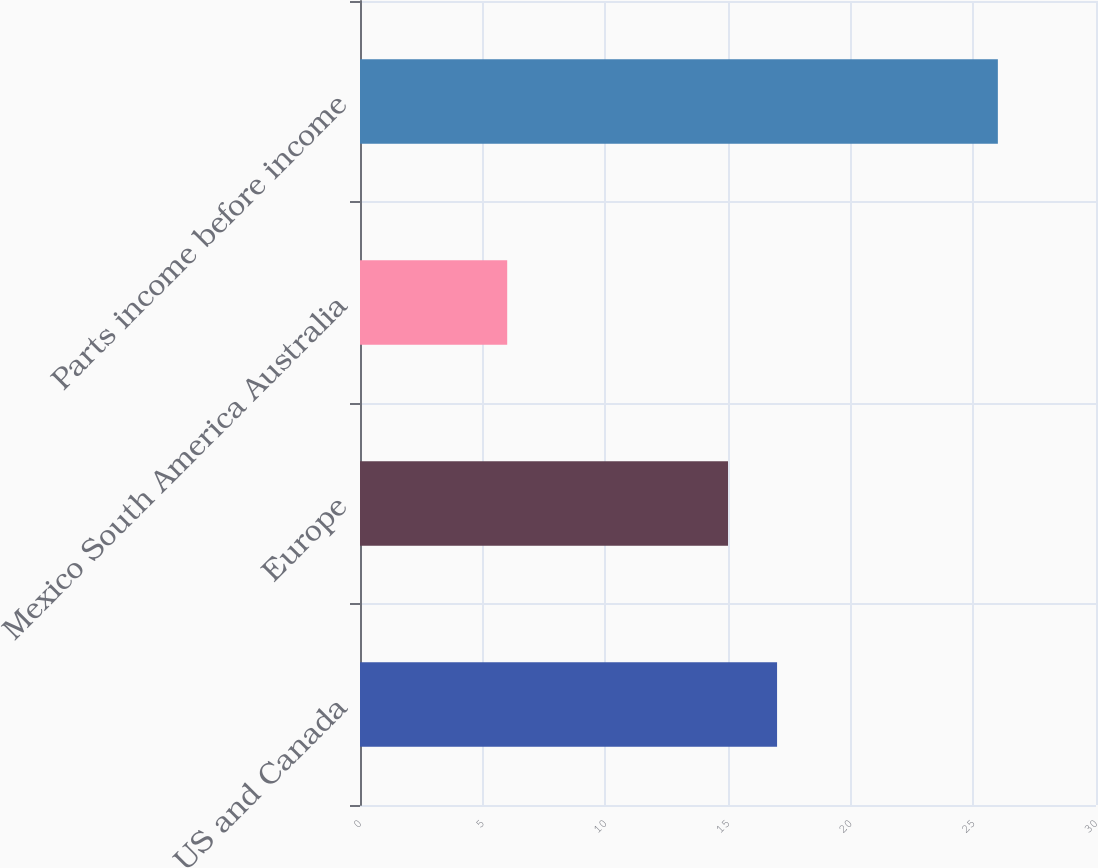Convert chart. <chart><loc_0><loc_0><loc_500><loc_500><bar_chart><fcel>US and Canada<fcel>Europe<fcel>Mexico South America Australia<fcel>Parts income before income<nl><fcel>17<fcel>15<fcel>6<fcel>26<nl></chart> 